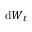<formula> <loc_0><loc_0><loc_500><loc_500>d { W _ { t } }</formula> 